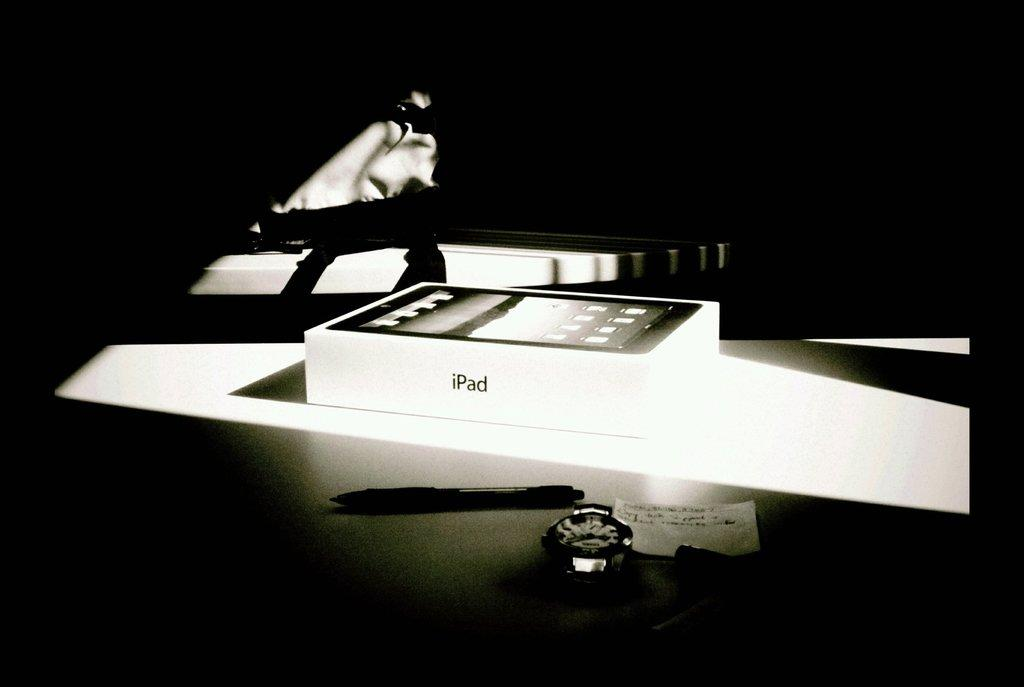<image>
Provide a brief description of the given image. A black and white photo of a white box that reads iPad. 